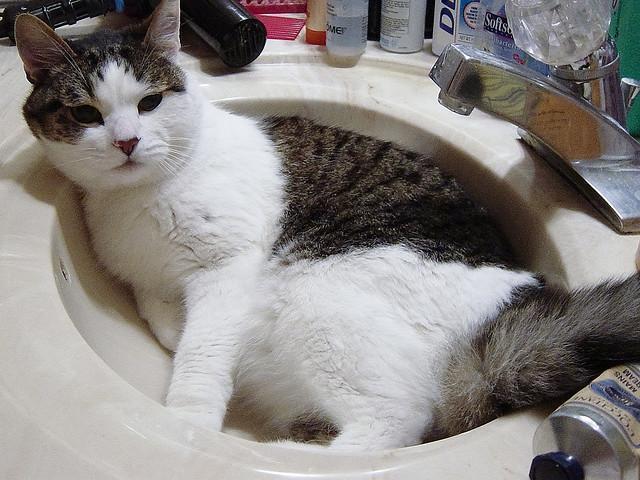Why is the cat in the sink?
From the following set of four choices, select the accurate answer to respond to the question.
Options: To sleep, to eat, to bathe, to comb. To sleep. 